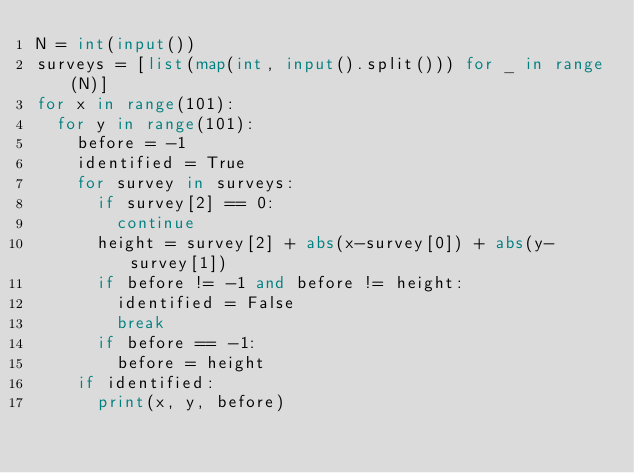<code> <loc_0><loc_0><loc_500><loc_500><_Python_>N = int(input())
surveys = [list(map(int, input().split())) for _ in range(N)]
for x in range(101):
  for y in range(101):
    before = -1
    identified = True
    for survey in surveys:
      if survey[2] == 0:
        continue
      height = survey[2] + abs(x-survey[0]) + abs(y-survey[1])
      if before != -1 and before != height:
        identified = False
        break
      if before == -1:
        before = height
    if identified:
      print(x, y, before)
</code> 